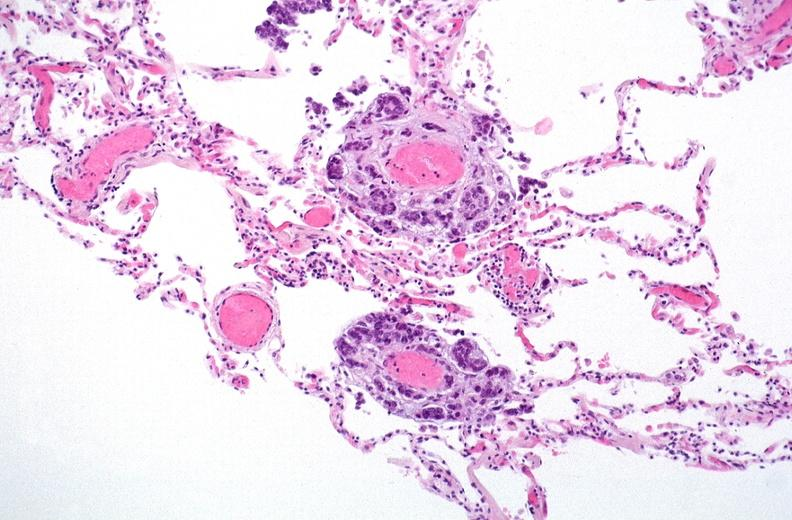what is present?
Answer the question using a single word or phrase. Respiratory 